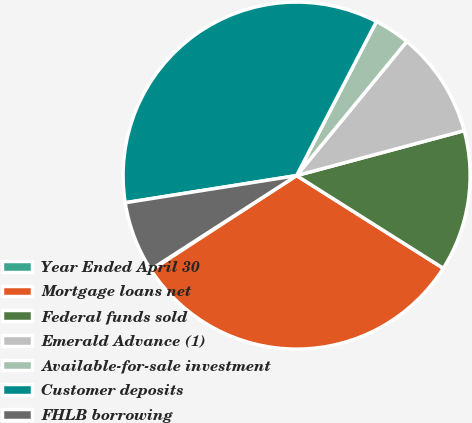Convert chart. <chart><loc_0><loc_0><loc_500><loc_500><pie_chart><fcel>Year Ended April 30<fcel>Mortgage loans net<fcel>Federal funds sold<fcel>Emerald Advance (1)<fcel>Available-for-sale investment<fcel>Customer deposits<fcel>FHLB borrowing<nl><fcel>0.08%<fcel>31.84%<fcel>13.14%<fcel>9.88%<fcel>3.34%<fcel>35.11%<fcel>6.61%<nl></chart> 